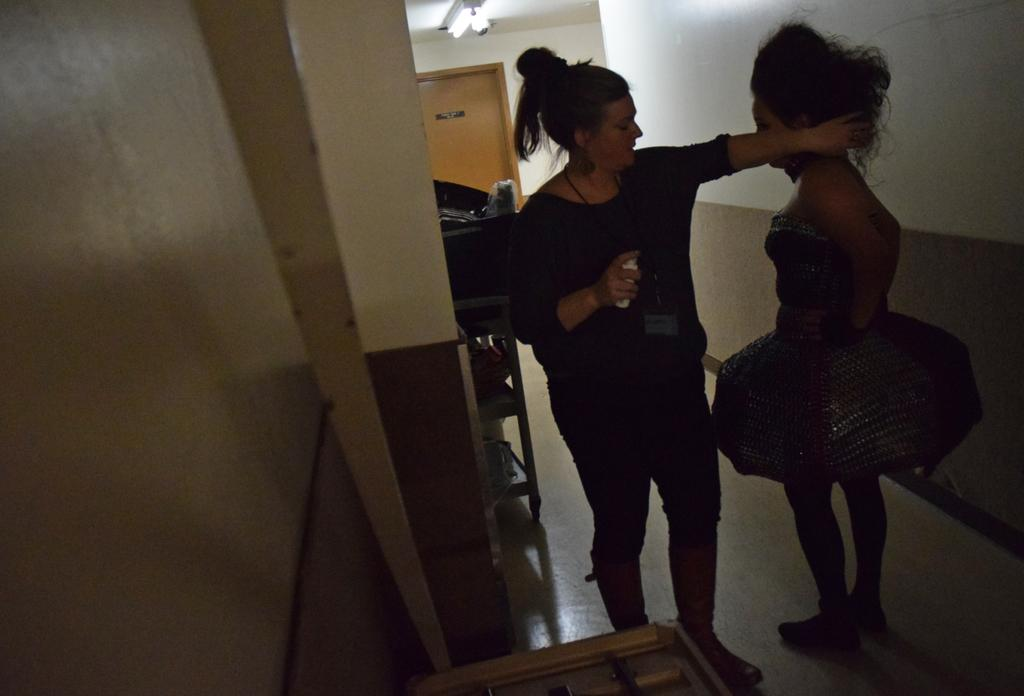How many women are present in the image? There are two women standing in the image. Where are the women located? The women are standing on a path in the image. What structure can be seen in the image? There is a door in the image, and a light is above the door. What type of background is visible in the image? There is a wall visible in the image. Can you see a tub in the image? No, there is no tub present in the image. Is there a goat or monkey visible in the image? No, there are no animals present in the image. 